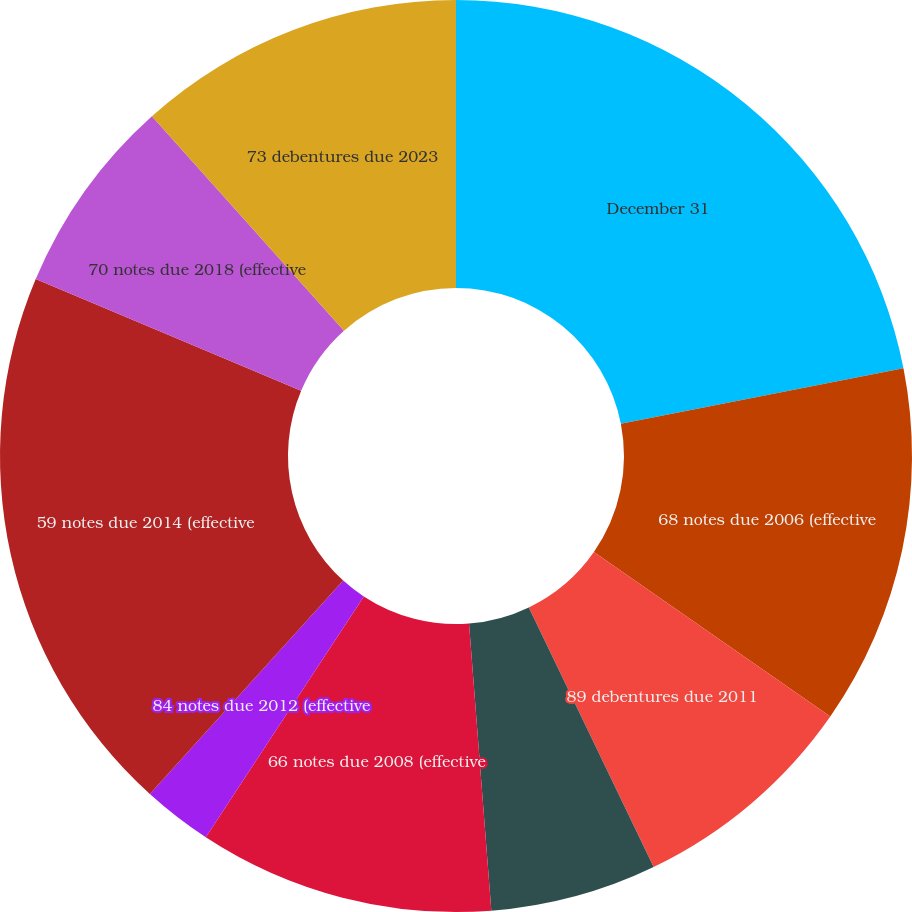<chart> <loc_0><loc_0><loc_500><loc_500><pie_chart><fcel>December 31<fcel>68 notes due 2006 (effective<fcel>89 debentures due 2011<fcel>65 notes due 2008 (effective<fcel>66 notes due 2008 (effective<fcel>84 notes due 2012 (effective<fcel>59 notes due 2014 (effective<fcel>70 notes due 2018 (effective<fcel>73 debentures due 2023<nl><fcel>21.92%<fcel>12.76%<fcel>8.19%<fcel>5.9%<fcel>10.48%<fcel>2.47%<fcel>19.63%<fcel>7.04%<fcel>11.62%<nl></chart> 